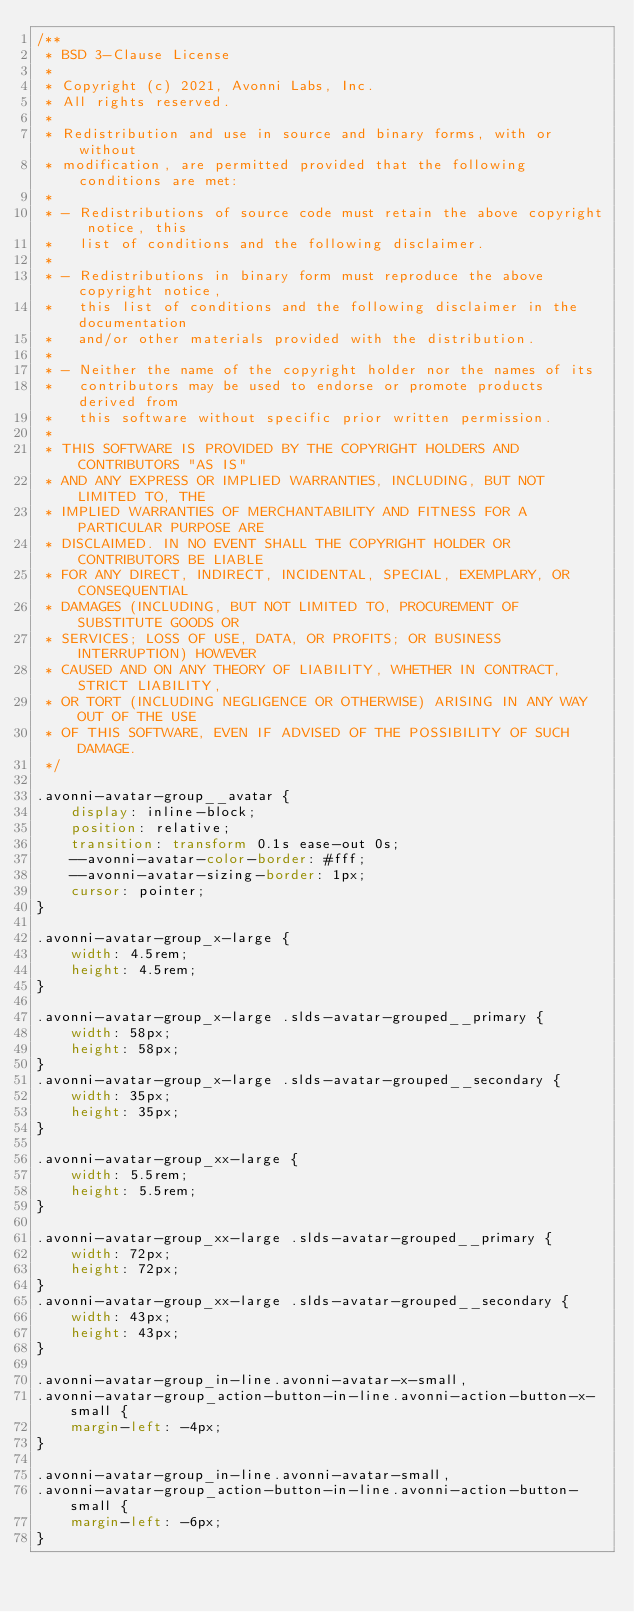<code> <loc_0><loc_0><loc_500><loc_500><_CSS_>/**
 * BSD 3-Clause License
 *
 * Copyright (c) 2021, Avonni Labs, Inc.
 * All rights reserved.
 *
 * Redistribution and use in source and binary forms, with or without
 * modification, are permitted provided that the following conditions are met:
 *
 * - Redistributions of source code must retain the above copyright notice, this
 *   list of conditions and the following disclaimer.
 *
 * - Redistributions in binary form must reproduce the above copyright notice,
 *   this list of conditions and the following disclaimer in the documentation
 *   and/or other materials provided with the distribution.
 *
 * - Neither the name of the copyright holder nor the names of its
 *   contributors may be used to endorse or promote products derived from
 *   this software without specific prior written permission.
 *
 * THIS SOFTWARE IS PROVIDED BY THE COPYRIGHT HOLDERS AND CONTRIBUTORS "AS IS"
 * AND ANY EXPRESS OR IMPLIED WARRANTIES, INCLUDING, BUT NOT LIMITED TO, THE
 * IMPLIED WARRANTIES OF MERCHANTABILITY AND FITNESS FOR A PARTICULAR PURPOSE ARE
 * DISCLAIMED. IN NO EVENT SHALL THE COPYRIGHT HOLDER OR CONTRIBUTORS BE LIABLE
 * FOR ANY DIRECT, INDIRECT, INCIDENTAL, SPECIAL, EXEMPLARY, OR CONSEQUENTIAL
 * DAMAGES (INCLUDING, BUT NOT LIMITED TO, PROCUREMENT OF SUBSTITUTE GOODS OR
 * SERVICES; LOSS OF USE, DATA, OR PROFITS; OR BUSINESS INTERRUPTION) HOWEVER
 * CAUSED AND ON ANY THEORY OF LIABILITY, WHETHER IN CONTRACT, STRICT LIABILITY,
 * OR TORT (INCLUDING NEGLIGENCE OR OTHERWISE) ARISING IN ANY WAY OUT OF THE USE
 * OF THIS SOFTWARE, EVEN IF ADVISED OF THE POSSIBILITY OF SUCH DAMAGE.
 */

.avonni-avatar-group__avatar {
    display: inline-block;
    position: relative;
    transition: transform 0.1s ease-out 0s;
    --avonni-avatar-color-border: #fff;
    --avonni-avatar-sizing-border: 1px;
    cursor: pointer;
}

.avonni-avatar-group_x-large {
    width: 4.5rem;
    height: 4.5rem;
}

.avonni-avatar-group_x-large .slds-avatar-grouped__primary {
    width: 58px;
    height: 58px;
}
.avonni-avatar-group_x-large .slds-avatar-grouped__secondary {
    width: 35px;
    height: 35px;
}

.avonni-avatar-group_xx-large {
    width: 5.5rem;
    height: 5.5rem;
}

.avonni-avatar-group_xx-large .slds-avatar-grouped__primary {
    width: 72px;
    height: 72px;
}
.avonni-avatar-group_xx-large .slds-avatar-grouped__secondary {
    width: 43px;
    height: 43px;
}

.avonni-avatar-group_in-line.avonni-avatar-x-small,
.avonni-avatar-group_action-button-in-line.avonni-action-button-x-small {
    margin-left: -4px;
}

.avonni-avatar-group_in-line.avonni-avatar-small,
.avonni-avatar-group_action-button-in-line.avonni-action-button-small {
    margin-left: -6px;
}
</code> 